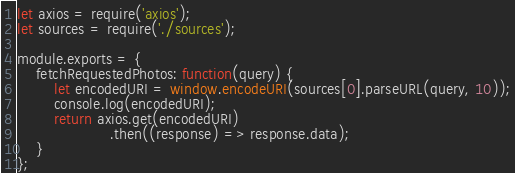<code> <loc_0><loc_0><loc_500><loc_500><_JavaScript_>let axios = require('axios');
let sources = require('./sources');

module.exports = {
    fetchRequestedPhotos: function(query) {
        let encodedURI = window.encodeURI(sources[0].parseURL(query, 10));
        console.log(encodedURI);
        return axios.get(encodedURI)
                    .then((response) => response.data);
    }
};
</code> 